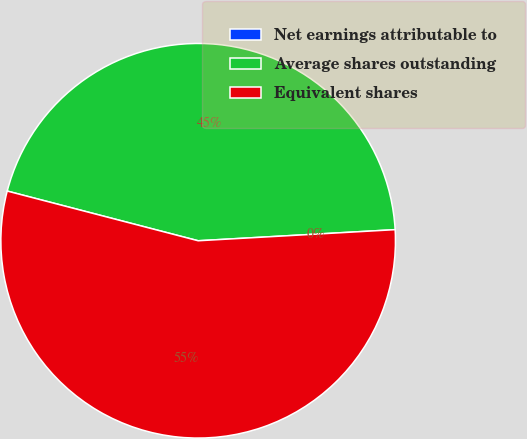Convert chart to OTSL. <chart><loc_0><loc_0><loc_500><loc_500><pie_chart><fcel>Net earnings attributable to<fcel>Average shares outstanding<fcel>Equivalent shares<nl><fcel>0.0%<fcel>45.05%<fcel>54.95%<nl></chart> 